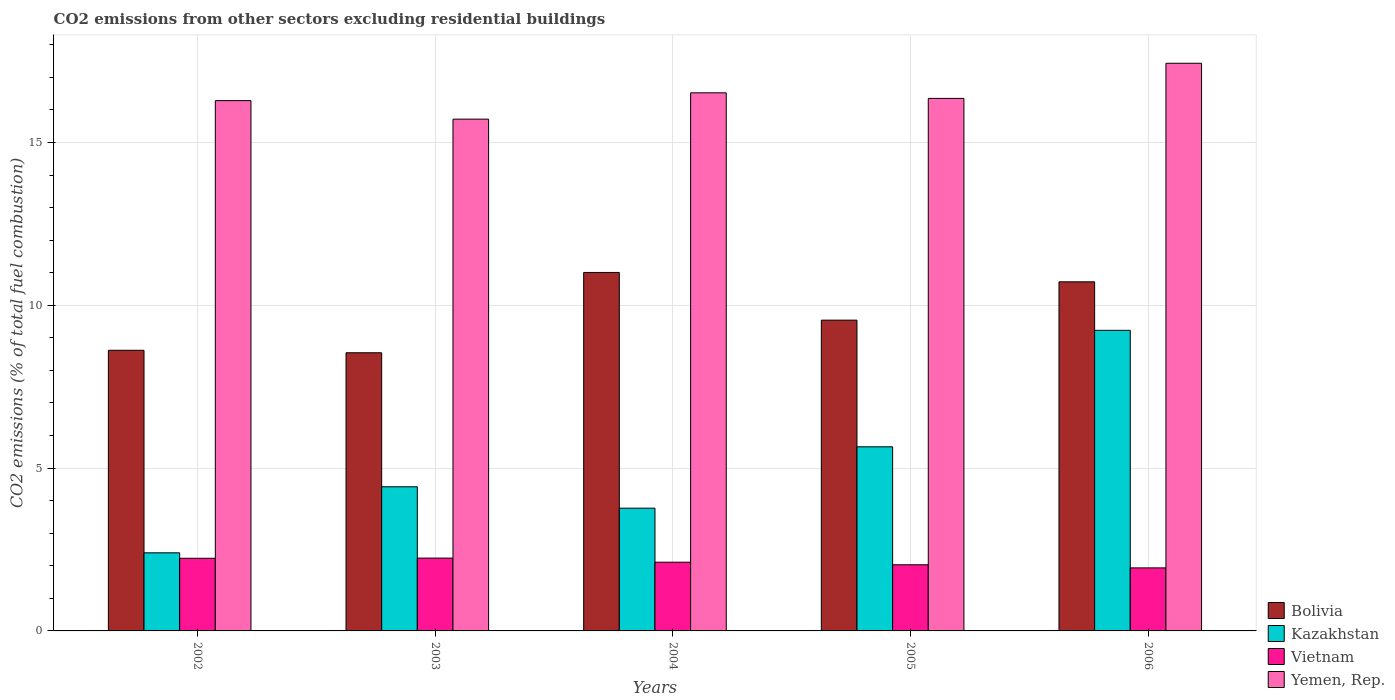How many groups of bars are there?
Make the answer very short. 5. Are the number of bars per tick equal to the number of legend labels?
Offer a very short reply. Yes. How many bars are there on the 2nd tick from the left?
Make the answer very short. 4. What is the total CO2 emitted in Bolivia in 2006?
Your response must be concise. 10.72. Across all years, what is the maximum total CO2 emitted in Bolivia?
Your answer should be very brief. 11.01. Across all years, what is the minimum total CO2 emitted in Bolivia?
Ensure brevity in your answer.  8.54. In which year was the total CO2 emitted in Yemen, Rep. minimum?
Your answer should be very brief. 2003. What is the total total CO2 emitted in Vietnam in the graph?
Give a very brief answer. 10.54. What is the difference between the total CO2 emitted in Bolivia in 2002 and that in 2005?
Give a very brief answer. -0.93. What is the difference between the total CO2 emitted in Yemen, Rep. in 2003 and the total CO2 emitted in Kazakhstan in 2004?
Provide a short and direct response. 11.95. What is the average total CO2 emitted in Bolivia per year?
Give a very brief answer. 9.69. In the year 2003, what is the difference between the total CO2 emitted in Vietnam and total CO2 emitted in Yemen, Rep.?
Offer a terse response. -13.48. In how many years, is the total CO2 emitted in Kazakhstan greater than 17?
Keep it short and to the point. 0. What is the ratio of the total CO2 emitted in Bolivia in 2005 to that in 2006?
Your response must be concise. 0.89. Is the total CO2 emitted in Vietnam in 2002 less than that in 2003?
Ensure brevity in your answer.  Yes. What is the difference between the highest and the second highest total CO2 emitted in Vietnam?
Provide a succinct answer. 0.01. What is the difference between the highest and the lowest total CO2 emitted in Bolivia?
Your answer should be compact. 2.47. In how many years, is the total CO2 emitted in Vietnam greater than the average total CO2 emitted in Vietnam taken over all years?
Offer a terse response. 3. Is the sum of the total CO2 emitted in Yemen, Rep. in 2003 and 2005 greater than the maximum total CO2 emitted in Vietnam across all years?
Provide a succinct answer. Yes. Is it the case that in every year, the sum of the total CO2 emitted in Kazakhstan and total CO2 emitted in Yemen, Rep. is greater than the sum of total CO2 emitted in Bolivia and total CO2 emitted in Vietnam?
Keep it short and to the point. No. What does the 2nd bar from the left in 2002 represents?
Make the answer very short. Kazakhstan. What does the 4th bar from the right in 2005 represents?
Make the answer very short. Bolivia. Is it the case that in every year, the sum of the total CO2 emitted in Vietnam and total CO2 emitted in Bolivia is greater than the total CO2 emitted in Kazakhstan?
Your response must be concise. Yes. How many bars are there?
Give a very brief answer. 20. Are all the bars in the graph horizontal?
Your response must be concise. No. Are the values on the major ticks of Y-axis written in scientific E-notation?
Ensure brevity in your answer.  No. Does the graph contain any zero values?
Give a very brief answer. No. Does the graph contain grids?
Ensure brevity in your answer.  Yes. How many legend labels are there?
Make the answer very short. 4. What is the title of the graph?
Your answer should be compact. CO2 emissions from other sectors excluding residential buildings. What is the label or title of the Y-axis?
Make the answer very short. CO2 emissions (% of total fuel combustion). What is the CO2 emissions (% of total fuel combustion) in Bolivia in 2002?
Provide a short and direct response. 8.62. What is the CO2 emissions (% of total fuel combustion) in Kazakhstan in 2002?
Your answer should be very brief. 2.4. What is the CO2 emissions (% of total fuel combustion) in Vietnam in 2002?
Your answer should be compact. 2.23. What is the CO2 emissions (% of total fuel combustion) in Yemen, Rep. in 2002?
Your answer should be compact. 16.29. What is the CO2 emissions (% of total fuel combustion) of Bolivia in 2003?
Offer a very short reply. 8.54. What is the CO2 emissions (% of total fuel combustion) in Kazakhstan in 2003?
Your answer should be very brief. 4.43. What is the CO2 emissions (% of total fuel combustion) of Vietnam in 2003?
Your answer should be compact. 2.24. What is the CO2 emissions (% of total fuel combustion) of Yemen, Rep. in 2003?
Provide a succinct answer. 15.72. What is the CO2 emissions (% of total fuel combustion) in Bolivia in 2004?
Keep it short and to the point. 11.01. What is the CO2 emissions (% of total fuel combustion) in Kazakhstan in 2004?
Offer a very short reply. 3.77. What is the CO2 emissions (% of total fuel combustion) of Vietnam in 2004?
Your answer should be very brief. 2.11. What is the CO2 emissions (% of total fuel combustion) in Yemen, Rep. in 2004?
Offer a very short reply. 16.53. What is the CO2 emissions (% of total fuel combustion) in Bolivia in 2005?
Offer a terse response. 9.54. What is the CO2 emissions (% of total fuel combustion) of Kazakhstan in 2005?
Your answer should be very brief. 5.65. What is the CO2 emissions (% of total fuel combustion) in Vietnam in 2005?
Provide a succinct answer. 2.03. What is the CO2 emissions (% of total fuel combustion) of Yemen, Rep. in 2005?
Offer a terse response. 16.35. What is the CO2 emissions (% of total fuel combustion) in Bolivia in 2006?
Keep it short and to the point. 10.72. What is the CO2 emissions (% of total fuel combustion) in Kazakhstan in 2006?
Offer a terse response. 9.23. What is the CO2 emissions (% of total fuel combustion) in Vietnam in 2006?
Offer a terse response. 1.94. What is the CO2 emissions (% of total fuel combustion) in Yemen, Rep. in 2006?
Give a very brief answer. 17.43. Across all years, what is the maximum CO2 emissions (% of total fuel combustion) of Bolivia?
Make the answer very short. 11.01. Across all years, what is the maximum CO2 emissions (% of total fuel combustion) in Kazakhstan?
Ensure brevity in your answer.  9.23. Across all years, what is the maximum CO2 emissions (% of total fuel combustion) in Vietnam?
Provide a succinct answer. 2.24. Across all years, what is the maximum CO2 emissions (% of total fuel combustion) in Yemen, Rep.?
Ensure brevity in your answer.  17.43. Across all years, what is the minimum CO2 emissions (% of total fuel combustion) in Bolivia?
Ensure brevity in your answer.  8.54. Across all years, what is the minimum CO2 emissions (% of total fuel combustion) of Kazakhstan?
Provide a succinct answer. 2.4. Across all years, what is the minimum CO2 emissions (% of total fuel combustion) of Vietnam?
Provide a short and direct response. 1.94. Across all years, what is the minimum CO2 emissions (% of total fuel combustion) of Yemen, Rep.?
Your answer should be very brief. 15.72. What is the total CO2 emissions (% of total fuel combustion) in Bolivia in the graph?
Give a very brief answer. 48.44. What is the total CO2 emissions (% of total fuel combustion) in Kazakhstan in the graph?
Make the answer very short. 25.48. What is the total CO2 emissions (% of total fuel combustion) in Vietnam in the graph?
Your answer should be very brief. 10.54. What is the total CO2 emissions (% of total fuel combustion) of Yemen, Rep. in the graph?
Give a very brief answer. 82.31. What is the difference between the CO2 emissions (% of total fuel combustion) of Bolivia in 2002 and that in 2003?
Your answer should be very brief. 0.08. What is the difference between the CO2 emissions (% of total fuel combustion) of Kazakhstan in 2002 and that in 2003?
Keep it short and to the point. -2.03. What is the difference between the CO2 emissions (% of total fuel combustion) in Vietnam in 2002 and that in 2003?
Provide a short and direct response. -0.01. What is the difference between the CO2 emissions (% of total fuel combustion) of Yemen, Rep. in 2002 and that in 2003?
Keep it short and to the point. 0.57. What is the difference between the CO2 emissions (% of total fuel combustion) of Bolivia in 2002 and that in 2004?
Your response must be concise. -2.39. What is the difference between the CO2 emissions (% of total fuel combustion) of Kazakhstan in 2002 and that in 2004?
Offer a very short reply. -1.37. What is the difference between the CO2 emissions (% of total fuel combustion) in Vietnam in 2002 and that in 2004?
Your answer should be compact. 0.12. What is the difference between the CO2 emissions (% of total fuel combustion) of Yemen, Rep. in 2002 and that in 2004?
Provide a short and direct response. -0.24. What is the difference between the CO2 emissions (% of total fuel combustion) of Bolivia in 2002 and that in 2005?
Keep it short and to the point. -0.93. What is the difference between the CO2 emissions (% of total fuel combustion) of Kazakhstan in 2002 and that in 2005?
Make the answer very short. -3.26. What is the difference between the CO2 emissions (% of total fuel combustion) in Vietnam in 2002 and that in 2005?
Make the answer very short. 0.2. What is the difference between the CO2 emissions (% of total fuel combustion) in Yemen, Rep. in 2002 and that in 2005?
Offer a very short reply. -0.07. What is the difference between the CO2 emissions (% of total fuel combustion) in Bolivia in 2002 and that in 2006?
Provide a short and direct response. -2.1. What is the difference between the CO2 emissions (% of total fuel combustion) of Kazakhstan in 2002 and that in 2006?
Offer a very short reply. -6.83. What is the difference between the CO2 emissions (% of total fuel combustion) in Vietnam in 2002 and that in 2006?
Ensure brevity in your answer.  0.3. What is the difference between the CO2 emissions (% of total fuel combustion) in Yemen, Rep. in 2002 and that in 2006?
Make the answer very short. -1.15. What is the difference between the CO2 emissions (% of total fuel combustion) in Bolivia in 2003 and that in 2004?
Your answer should be very brief. -2.47. What is the difference between the CO2 emissions (% of total fuel combustion) of Kazakhstan in 2003 and that in 2004?
Offer a terse response. 0.66. What is the difference between the CO2 emissions (% of total fuel combustion) in Vietnam in 2003 and that in 2004?
Provide a succinct answer. 0.13. What is the difference between the CO2 emissions (% of total fuel combustion) of Yemen, Rep. in 2003 and that in 2004?
Keep it short and to the point. -0.81. What is the difference between the CO2 emissions (% of total fuel combustion) in Bolivia in 2003 and that in 2005?
Ensure brevity in your answer.  -1. What is the difference between the CO2 emissions (% of total fuel combustion) of Kazakhstan in 2003 and that in 2005?
Offer a very short reply. -1.23. What is the difference between the CO2 emissions (% of total fuel combustion) in Vietnam in 2003 and that in 2005?
Offer a terse response. 0.21. What is the difference between the CO2 emissions (% of total fuel combustion) of Yemen, Rep. in 2003 and that in 2005?
Your answer should be very brief. -0.64. What is the difference between the CO2 emissions (% of total fuel combustion) in Bolivia in 2003 and that in 2006?
Your answer should be compact. -2.18. What is the difference between the CO2 emissions (% of total fuel combustion) in Kazakhstan in 2003 and that in 2006?
Provide a short and direct response. -4.81. What is the difference between the CO2 emissions (% of total fuel combustion) in Vietnam in 2003 and that in 2006?
Your answer should be compact. 0.3. What is the difference between the CO2 emissions (% of total fuel combustion) of Yemen, Rep. in 2003 and that in 2006?
Keep it short and to the point. -1.72. What is the difference between the CO2 emissions (% of total fuel combustion) in Bolivia in 2004 and that in 2005?
Provide a short and direct response. 1.47. What is the difference between the CO2 emissions (% of total fuel combustion) of Kazakhstan in 2004 and that in 2005?
Your answer should be very brief. -1.88. What is the difference between the CO2 emissions (% of total fuel combustion) in Vietnam in 2004 and that in 2005?
Offer a very short reply. 0.08. What is the difference between the CO2 emissions (% of total fuel combustion) in Yemen, Rep. in 2004 and that in 2005?
Ensure brevity in your answer.  0.17. What is the difference between the CO2 emissions (% of total fuel combustion) of Bolivia in 2004 and that in 2006?
Offer a terse response. 0.29. What is the difference between the CO2 emissions (% of total fuel combustion) in Kazakhstan in 2004 and that in 2006?
Your response must be concise. -5.46. What is the difference between the CO2 emissions (% of total fuel combustion) of Vietnam in 2004 and that in 2006?
Your response must be concise. 0.17. What is the difference between the CO2 emissions (% of total fuel combustion) in Yemen, Rep. in 2004 and that in 2006?
Your answer should be very brief. -0.91. What is the difference between the CO2 emissions (% of total fuel combustion) in Bolivia in 2005 and that in 2006?
Keep it short and to the point. -1.18. What is the difference between the CO2 emissions (% of total fuel combustion) of Kazakhstan in 2005 and that in 2006?
Make the answer very short. -3.58. What is the difference between the CO2 emissions (% of total fuel combustion) of Vietnam in 2005 and that in 2006?
Provide a succinct answer. 0.1. What is the difference between the CO2 emissions (% of total fuel combustion) of Yemen, Rep. in 2005 and that in 2006?
Offer a terse response. -1.08. What is the difference between the CO2 emissions (% of total fuel combustion) in Bolivia in 2002 and the CO2 emissions (% of total fuel combustion) in Kazakhstan in 2003?
Keep it short and to the point. 4.19. What is the difference between the CO2 emissions (% of total fuel combustion) in Bolivia in 2002 and the CO2 emissions (% of total fuel combustion) in Vietnam in 2003?
Provide a succinct answer. 6.38. What is the difference between the CO2 emissions (% of total fuel combustion) in Bolivia in 2002 and the CO2 emissions (% of total fuel combustion) in Yemen, Rep. in 2003?
Provide a succinct answer. -7.1. What is the difference between the CO2 emissions (% of total fuel combustion) of Kazakhstan in 2002 and the CO2 emissions (% of total fuel combustion) of Vietnam in 2003?
Offer a terse response. 0.16. What is the difference between the CO2 emissions (% of total fuel combustion) in Kazakhstan in 2002 and the CO2 emissions (% of total fuel combustion) in Yemen, Rep. in 2003?
Your answer should be very brief. -13.32. What is the difference between the CO2 emissions (% of total fuel combustion) of Vietnam in 2002 and the CO2 emissions (% of total fuel combustion) of Yemen, Rep. in 2003?
Your answer should be very brief. -13.49. What is the difference between the CO2 emissions (% of total fuel combustion) in Bolivia in 2002 and the CO2 emissions (% of total fuel combustion) in Kazakhstan in 2004?
Your response must be concise. 4.85. What is the difference between the CO2 emissions (% of total fuel combustion) in Bolivia in 2002 and the CO2 emissions (% of total fuel combustion) in Vietnam in 2004?
Give a very brief answer. 6.51. What is the difference between the CO2 emissions (% of total fuel combustion) of Bolivia in 2002 and the CO2 emissions (% of total fuel combustion) of Yemen, Rep. in 2004?
Make the answer very short. -7.91. What is the difference between the CO2 emissions (% of total fuel combustion) of Kazakhstan in 2002 and the CO2 emissions (% of total fuel combustion) of Vietnam in 2004?
Provide a succinct answer. 0.29. What is the difference between the CO2 emissions (% of total fuel combustion) in Kazakhstan in 2002 and the CO2 emissions (% of total fuel combustion) in Yemen, Rep. in 2004?
Provide a succinct answer. -14.13. What is the difference between the CO2 emissions (% of total fuel combustion) in Vietnam in 2002 and the CO2 emissions (% of total fuel combustion) in Yemen, Rep. in 2004?
Ensure brevity in your answer.  -14.29. What is the difference between the CO2 emissions (% of total fuel combustion) in Bolivia in 2002 and the CO2 emissions (% of total fuel combustion) in Kazakhstan in 2005?
Your response must be concise. 2.96. What is the difference between the CO2 emissions (% of total fuel combustion) of Bolivia in 2002 and the CO2 emissions (% of total fuel combustion) of Vietnam in 2005?
Keep it short and to the point. 6.59. What is the difference between the CO2 emissions (% of total fuel combustion) in Bolivia in 2002 and the CO2 emissions (% of total fuel combustion) in Yemen, Rep. in 2005?
Your response must be concise. -7.74. What is the difference between the CO2 emissions (% of total fuel combustion) in Kazakhstan in 2002 and the CO2 emissions (% of total fuel combustion) in Vietnam in 2005?
Your answer should be compact. 0.37. What is the difference between the CO2 emissions (% of total fuel combustion) of Kazakhstan in 2002 and the CO2 emissions (% of total fuel combustion) of Yemen, Rep. in 2005?
Give a very brief answer. -13.96. What is the difference between the CO2 emissions (% of total fuel combustion) of Vietnam in 2002 and the CO2 emissions (% of total fuel combustion) of Yemen, Rep. in 2005?
Your response must be concise. -14.12. What is the difference between the CO2 emissions (% of total fuel combustion) of Bolivia in 2002 and the CO2 emissions (% of total fuel combustion) of Kazakhstan in 2006?
Offer a very short reply. -0.61. What is the difference between the CO2 emissions (% of total fuel combustion) of Bolivia in 2002 and the CO2 emissions (% of total fuel combustion) of Vietnam in 2006?
Keep it short and to the point. 6.68. What is the difference between the CO2 emissions (% of total fuel combustion) in Bolivia in 2002 and the CO2 emissions (% of total fuel combustion) in Yemen, Rep. in 2006?
Provide a short and direct response. -8.81. What is the difference between the CO2 emissions (% of total fuel combustion) in Kazakhstan in 2002 and the CO2 emissions (% of total fuel combustion) in Vietnam in 2006?
Make the answer very short. 0.46. What is the difference between the CO2 emissions (% of total fuel combustion) in Kazakhstan in 2002 and the CO2 emissions (% of total fuel combustion) in Yemen, Rep. in 2006?
Your answer should be compact. -15.03. What is the difference between the CO2 emissions (% of total fuel combustion) of Vietnam in 2002 and the CO2 emissions (% of total fuel combustion) of Yemen, Rep. in 2006?
Provide a short and direct response. -15.2. What is the difference between the CO2 emissions (% of total fuel combustion) in Bolivia in 2003 and the CO2 emissions (% of total fuel combustion) in Kazakhstan in 2004?
Provide a succinct answer. 4.77. What is the difference between the CO2 emissions (% of total fuel combustion) of Bolivia in 2003 and the CO2 emissions (% of total fuel combustion) of Vietnam in 2004?
Your answer should be compact. 6.43. What is the difference between the CO2 emissions (% of total fuel combustion) in Bolivia in 2003 and the CO2 emissions (% of total fuel combustion) in Yemen, Rep. in 2004?
Keep it short and to the point. -7.98. What is the difference between the CO2 emissions (% of total fuel combustion) in Kazakhstan in 2003 and the CO2 emissions (% of total fuel combustion) in Vietnam in 2004?
Provide a succinct answer. 2.32. What is the difference between the CO2 emissions (% of total fuel combustion) in Kazakhstan in 2003 and the CO2 emissions (% of total fuel combustion) in Yemen, Rep. in 2004?
Your answer should be compact. -12.1. What is the difference between the CO2 emissions (% of total fuel combustion) of Vietnam in 2003 and the CO2 emissions (% of total fuel combustion) of Yemen, Rep. in 2004?
Your response must be concise. -14.29. What is the difference between the CO2 emissions (% of total fuel combustion) of Bolivia in 2003 and the CO2 emissions (% of total fuel combustion) of Kazakhstan in 2005?
Provide a short and direct response. 2.89. What is the difference between the CO2 emissions (% of total fuel combustion) of Bolivia in 2003 and the CO2 emissions (% of total fuel combustion) of Vietnam in 2005?
Provide a short and direct response. 6.51. What is the difference between the CO2 emissions (% of total fuel combustion) of Bolivia in 2003 and the CO2 emissions (% of total fuel combustion) of Yemen, Rep. in 2005?
Offer a terse response. -7.81. What is the difference between the CO2 emissions (% of total fuel combustion) in Kazakhstan in 2003 and the CO2 emissions (% of total fuel combustion) in Vietnam in 2005?
Keep it short and to the point. 2.4. What is the difference between the CO2 emissions (% of total fuel combustion) of Kazakhstan in 2003 and the CO2 emissions (% of total fuel combustion) of Yemen, Rep. in 2005?
Ensure brevity in your answer.  -11.93. What is the difference between the CO2 emissions (% of total fuel combustion) of Vietnam in 2003 and the CO2 emissions (% of total fuel combustion) of Yemen, Rep. in 2005?
Your answer should be compact. -14.12. What is the difference between the CO2 emissions (% of total fuel combustion) in Bolivia in 2003 and the CO2 emissions (% of total fuel combustion) in Kazakhstan in 2006?
Give a very brief answer. -0.69. What is the difference between the CO2 emissions (% of total fuel combustion) in Bolivia in 2003 and the CO2 emissions (% of total fuel combustion) in Vietnam in 2006?
Provide a succinct answer. 6.61. What is the difference between the CO2 emissions (% of total fuel combustion) in Bolivia in 2003 and the CO2 emissions (% of total fuel combustion) in Yemen, Rep. in 2006?
Offer a very short reply. -8.89. What is the difference between the CO2 emissions (% of total fuel combustion) in Kazakhstan in 2003 and the CO2 emissions (% of total fuel combustion) in Vietnam in 2006?
Provide a short and direct response. 2.49. What is the difference between the CO2 emissions (% of total fuel combustion) of Kazakhstan in 2003 and the CO2 emissions (% of total fuel combustion) of Yemen, Rep. in 2006?
Make the answer very short. -13.01. What is the difference between the CO2 emissions (% of total fuel combustion) of Vietnam in 2003 and the CO2 emissions (% of total fuel combustion) of Yemen, Rep. in 2006?
Your response must be concise. -15.2. What is the difference between the CO2 emissions (% of total fuel combustion) of Bolivia in 2004 and the CO2 emissions (% of total fuel combustion) of Kazakhstan in 2005?
Offer a terse response. 5.35. What is the difference between the CO2 emissions (% of total fuel combustion) in Bolivia in 2004 and the CO2 emissions (% of total fuel combustion) in Vietnam in 2005?
Offer a very short reply. 8.98. What is the difference between the CO2 emissions (% of total fuel combustion) of Bolivia in 2004 and the CO2 emissions (% of total fuel combustion) of Yemen, Rep. in 2005?
Give a very brief answer. -5.34. What is the difference between the CO2 emissions (% of total fuel combustion) in Kazakhstan in 2004 and the CO2 emissions (% of total fuel combustion) in Vietnam in 2005?
Make the answer very short. 1.74. What is the difference between the CO2 emissions (% of total fuel combustion) of Kazakhstan in 2004 and the CO2 emissions (% of total fuel combustion) of Yemen, Rep. in 2005?
Your answer should be compact. -12.58. What is the difference between the CO2 emissions (% of total fuel combustion) of Vietnam in 2004 and the CO2 emissions (% of total fuel combustion) of Yemen, Rep. in 2005?
Provide a succinct answer. -14.24. What is the difference between the CO2 emissions (% of total fuel combustion) in Bolivia in 2004 and the CO2 emissions (% of total fuel combustion) in Kazakhstan in 2006?
Ensure brevity in your answer.  1.78. What is the difference between the CO2 emissions (% of total fuel combustion) of Bolivia in 2004 and the CO2 emissions (% of total fuel combustion) of Vietnam in 2006?
Provide a short and direct response. 9.07. What is the difference between the CO2 emissions (% of total fuel combustion) of Bolivia in 2004 and the CO2 emissions (% of total fuel combustion) of Yemen, Rep. in 2006?
Your answer should be very brief. -6.42. What is the difference between the CO2 emissions (% of total fuel combustion) of Kazakhstan in 2004 and the CO2 emissions (% of total fuel combustion) of Vietnam in 2006?
Provide a short and direct response. 1.83. What is the difference between the CO2 emissions (% of total fuel combustion) in Kazakhstan in 2004 and the CO2 emissions (% of total fuel combustion) in Yemen, Rep. in 2006?
Give a very brief answer. -13.66. What is the difference between the CO2 emissions (% of total fuel combustion) of Vietnam in 2004 and the CO2 emissions (% of total fuel combustion) of Yemen, Rep. in 2006?
Provide a short and direct response. -15.32. What is the difference between the CO2 emissions (% of total fuel combustion) in Bolivia in 2005 and the CO2 emissions (% of total fuel combustion) in Kazakhstan in 2006?
Keep it short and to the point. 0.31. What is the difference between the CO2 emissions (% of total fuel combustion) in Bolivia in 2005 and the CO2 emissions (% of total fuel combustion) in Vietnam in 2006?
Provide a short and direct response. 7.61. What is the difference between the CO2 emissions (% of total fuel combustion) in Bolivia in 2005 and the CO2 emissions (% of total fuel combustion) in Yemen, Rep. in 2006?
Give a very brief answer. -7.89. What is the difference between the CO2 emissions (% of total fuel combustion) of Kazakhstan in 2005 and the CO2 emissions (% of total fuel combustion) of Vietnam in 2006?
Offer a very short reply. 3.72. What is the difference between the CO2 emissions (% of total fuel combustion) in Kazakhstan in 2005 and the CO2 emissions (% of total fuel combustion) in Yemen, Rep. in 2006?
Provide a succinct answer. -11.78. What is the difference between the CO2 emissions (% of total fuel combustion) of Vietnam in 2005 and the CO2 emissions (% of total fuel combustion) of Yemen, Rep. in 2006?
Your answer should be compact. -15.4. What is the average CO2 emissions (% of total fuel combustion) in Bolivia per year?
Your response must be concise. 9.69. What is the average CO2 emissions (% of total fuel combustion) in Kazakhstan per year?
Provide a succinct answer. 5.1. What is the average CO2 emissions (% of total fuel combustion) of Vietnam per year?
Give a very brief answer. 2.11. What is the average CO2 emissions (% of total fuel combustion) of Yemen, Rep. per year?
Provide a succinct answer. 16.46. In the year 2002, what is the difference between the CO2 emissions (% of total fuel combustion) in Bolivia and CO2 emissions (% of total fuel combustion) in Kazakhstan?
Offer a terse response. 6.22. In the year 2002, what is the difference between the CO2 emissions (% of total fuel combustion) of Bolivia and CO2 emissions (% of total fuel combustion) of Vietnam?
Your response must be concise. 6.39. In the year 2002, what is the difference between the CO2 emissions (% of total fuel combustion) of Bolivia and CO2 emissions (% of total fuel combustion) of Yemen, Rep.?
Give a very brief answer. -7.67. In the year 2002, what is the difference between the CO2 emissions (% of total fuel combustion) in Kazakhstan and CO2 emissions (% of total fuel combustion) in Vietnam?
Your answer should be compact. 0.17. In the year 2002, what is the difference between the CO2 emissions (% of total fuel combustion) of Kazakhstan and CO2 emissions (% of total fuel combustion) of Yemen, Rep.?
Provide a succinct answer. -13.89. In the year 2002, what is the difference between the CO2 emissions (% of total fuel combustion) of Vietnam and CO2 emissions (% of total fuel combustion) of Yemen, Rep.?
Ensure brevity in your answer.  -14.05. In the year 2003, what is the difference between the CO2 emissions (% of total fuel combustion) in Bolivia and CO2 emissions (% of total fuel combustion) in Kazakhstan?
Your answer should be compact. 4.12. In the year 2003, what is the difference between the CO2 emissions (% of total fuel combustion) in Bolivia and CO2 emissions (% of total fuel combustion) in Vietnam?
Your response must be concise. 6.31. In the year 2003, what is the difference between the CO2 emissions (% of total fuel combustion) in Bolivia and CO2 emissions (% of total fuel combustion) in Yemen, Rep.?
Make the answer very short. -7.17. In the year 2003, what is the difference between the CO2 emissions (% of total fuel combustion) in Kazakhstan and CO2 emissions (% of total fuel combustion) in Vietnam?
Provide a short and direct response. 2.19. In the year 2003, what is the difference between the CO2 emissions (% of total fuel combustion) in Kazakhstan and CO2 emissions (% of total fuel combustion) in Yemen, Rep.?
Keep it short and to the point. -11.29. In the year 2003, what is the difference between the CO2 emissions (% of total fuel combustion) of Vietnam and CO2 emissions (% of total fuel combustion) of Yemen, Rep.?
Your answer should be compact. -13.48. In the year 2004, what is the difference between the CO2 emissions (% of total fuel combustion) of Bolivia and CO2 emissions (% of total fuel combustion) of Kazakhstan?
Your answer should be very brief. 7.24. In the year 2004, what is the difference between the CO2 emissions (% of total fuel combustion) in Bolivia and CO2 emissions (% of total fuel combustion) in Vietnam?
Provide a short and direct response. 8.9. In the year 2004, what is the difference between the CO2 emissions (% of total fuel combustion) of Bolivia and CO2 emissions (% of total fuel combustion) of Yemen, Rep.?
Keep it short and to the point. -5.52. In the year 2004, what is the difference between the CO2 emissions (% of total fuel combustion) in Kazakhstan and CO2 emissions (% of total fuel combustion) in Vietnam?
Your answer should be compact. 1.66. In the year 2004, what is the difference between the CO2 emissions (% of total fuel combustion) of Kazakhstan and CO2 emissions (% of total fuel combustion) of Yemen, Rep.?
Provide a succinct answer. -12.76. In the year 2004, what is the difference between the CO2 emissions (% of total fuel combustion) of Vietnam and CO2 emissions (% of total fuel combustion) of Yemen, Rep.?
Offer a very short reply. -14.42. In the year 2005, what is the difference between the CO2 emissions (% of total fuel combustion) of Bolivia and CO2 emissions (% of total fuel combustion) of Kazakhstan?
Make the answer very short. 3.89. In the year 2005, what is the difference between the CO2 emissions (% of total fuel combustion) in Bolivia and CO2 emissions (% of total fuel combustion) in Vietnam?
Give a very brief answer. 7.51. In the year 2005, what is the difference between the CO2 emissions (% of total fuel combustion) in Bolivia and CO2 emissions (% of total fuel combustion) in Yemen, Rep.?
Offer a terse response. -6.81. In the year 2005, what is the difference between the CO2 emissions (% of total fuel combustion) in Kazakhstan and CO2 emissions (% of total fuel combustion) in Vietnam?
Provide a short and direct response. 3.62. In the year 2005, what is the difference between the CO2 emissions (% of total fuel combustion) of Kazakhstan and CO2 emissions (% of total fuel combustion) of Yemen, Rep.?
Provide a short and direct response. -10.7. In the year 2005, what is the difference between the CO2 emissions (% of total fuel combustion) of Vietnam and CO2 emissions (% of total fuel combustion) of Yemen, Rep.?
Ensure brevity in your answer.  -14.32. In the year 2006, what is the difference between the CO2 emissions (% of total fuel combustion) of Bolivia and CO2 emissions (% of total fuel combustion) of Kazakhstan?
Provide a succinct answer. 1.49. In the year 2006, what is the difference between the CO2 emissions (% of total fuel combustion) in Bolivia and CO2 emissions (% of total fuel combustion) in Vietnam?
Make the answer very short. 8.79. In the year 2006, what is the difference between the CO2 emissions (% of total fuel combustion) of Bolivia and CO2 emissions (% of total fuel combustion) of Yemen, Rep.?
Make the answer very short. -6.71. In the year 2006, what is the difference between the CO2 emissions (% of total fuel combustion) of Kazakhstan and CO2 emissions (% of total fuel combustion) of Vietnam?
Your answer should be very brief. 7.3. In the year 2006, what is the difference between the CO2 emissions (% of total fuel combustion) in Kazakhstan and CO2 emissions (% of total fuel combustion) in Yemen, Rep.?
Provide a succinct answer. -8.2. In the year 2006, what is the difference between the CO2 emissions (% of total fuel combustion) in Vietnam and CO2 emissions (% of total fuel combustion) in Yemen, Rep.?
Keep it short and to the point. -15.5. What is the ratio of the CO2 emissions (% of total fuel combustion) of Bolivia in 2002 to that in 2003?
Ensure brevity in your answer.  1.01. What is the ratio of the CO2 emissions (% of total fuel combustion) in Kazakhstan in 2002 to that in 2003?
Your answer should be very brief. 0.54. What is the ratio of the CO2 emissions (% of total fuel combustion) in Yemen, Rep. in 2002 to that in 2003?
Your answer should be compact. 1.04. What is the ratio of the CO2 emissions (% of total fuel combustion) of Bolivia in 2002 to that in 2004?
Your answer should be very brief. 0.78. What is the ratio of the CO2 emissions (% of total fuel combustion) in Kazakhstan in 2002 to that in 2004?
Your answer should be very brief. 0.64. What is the ratio of the CO2 emissions (% of total fuel combustion) of Vietnam in 2002 to that in 2004?
Keep it short and to the point. 1.06. What is the ratio of the CO2 emissions (% of total fuel combustion) in Yemen, Rep. in 2002 to that in 2004?
Give a very brief answer. 0.99. What is the ratio of the CO2 emissions (% of total fuel combustion) in Bolivia in 2002 to that in 2005?
Ensure brevity in your answer.  0.9. What is the ratio of the CO2 emissions (% of total fuel combustion) in Kazakhstan in 2002 to that in 2005?
Offer a very short reply. 0.42. What is the ratio of the CO2 emissions (% of total fuel combustion) of Vietnam in 2002 to that in 2005?
Offer a terse response. 1.1. What is the ratio of the CO2 emissions (% of total fuel combustion) of Bolivia in 2002 to that in 2006?
Make the answer very short. 0.8. What is the ratio of the CO2 emissions (% of total fuel combustion) in Kazakhstan in 2002 to that in 2006?
Offer a terse response. 0.26. What is the ratio of the CO2 emissions (% of total fuel combustion) in Vietnam in 2002 to that in 2006?
Make the answer very short. 1.15. What is the ratio of the CO2 emissions (% of total fuel combustion) in Yemen, Rep. in 2002 to that in 2006?
Offer a terse response. 0.93. What is the ratio of the CO2 emissions (% of total fuel combustion) in Bolivia in 2003 to that in 2004?
Your answer should be compact. 0.78. What is the ratio of the CO2 emissions (% of total fuel combustion) in Kazakhstan in 2003 to that in 2004?
Provide a short and direct response. 1.17. What is the ratio of the CO2 emissions (% of total fuel combustion) in Vietnam in 2003 to that in 2004?
Ensure brevity in your answer.  1.06. What is the ratio of the CO2 emissions (% of total fuel combustion) in Yemen, Rep. in 2003 to that in 2004?
Provide a succinct answer. 0.95. What is the ratio of the CO2 emissions (% of total fuel combustion) of Bolivia in 2003 to that in 2005?
Your response must be concise. 0.9. What is the ratio of the CO2 emissions (% of total fuel combustion) in Kazakhstan in 2003 to that in 2005?
Your answer should be compact. 0.78. What is the ratio of the CO2 emissions (% of total fuel combustion) of Vietnam in 2003 to that in 2005?
Provide a succinct answer. 1.1. What is the ratio of the CO2 emissions (% of total fuel combustion) of Yemen, Rep. in 2003 to that in 2005?
Offer a terse response. 0.96. What is the ratio of the CO2 emissions (% of total fuel combustion) in Bolivia in 2003 to that in 2006?
Keep it short and to the point. 0.8. What is the ratio of the CO2 emissions (% of total fuel combustion) of Kazakhstan in 2003 to that in 2006?
Offer a terse response. 0.48. What is the ratio of the CO2 emissions (% of total fuel combustion) of Vietnam in 2003 to that in 2006?
Provide a short and direct response. 1.16. What is the ratio of the CO2 emissions (% of total fuel combustion) of Yemen, Rep. in 2003 to that in 2006?
Make the answer very short. 0.9. What is the ratio of the CO2 emissions (% of total fuel combustion) in Bolivia in 2004 to that in 2005?
Make the answer very short. 1.15. What is the ratio of the CO2 emissions (% of total fuel combustion) of Kazakhstan in 2004 to that in 2005?
Ensure brevity in your answer.  0.67. What is the ratio of the CO2 emissions (% of total fuel combustion) in Vietnam in 2004 to that in 2005?
Your answer should be very brief. 1.04. What is the ratio of the CO2 emissions (% of total fuel combustion) in Yemen, Rep. in 2004 to that in 2005?
Give a very brief answer. 1.01. What is the ratio of the CO2 emissions (% of total fuel combustion) in Bolivia in 2004 to that in 2006?
Keep it short and to the point. 1.03. What is the ratio of the CO2 emissions (% of total fuel combustion) in Kazakhstan in 2004 to that in 2006?
Provide a short and direct response. 0.41. What is the ratio of the CO2 emissions (% of total fuel combustion) of Vietnam in 2004 to that in 2006?
Your answer should be compact. 1.09. What is the ratio of the CO2 emissions (% of total fuel combustion) in Yemen, Rep. in 2004 to that in 2006?
Offer a very short reply. 0.95. What is the ratio of the CO2 emissions (% of total fuel combustion) in Bolivia in 2005 to that in 2006?
Give a very brief answer. 0.89. What is the ratio of the CO2 emissions (% of total fuel combustion) of Kazakhstan in 2005 to that in 2006?
Give a very brief answer. 0.61. What is the ratio of the CO2 emissions (% of total fuel combustion) in Vietnam in 2005 to that in 2006?
Your response must be concise. 1.05. What is the ratio of the CO2 emissions (% of total fuel combustion) of Yemen, Rep. in 2005 to that in 2006?
Provide a short and direct response. 0.94. What is the difference between the highest and the second highest CO2 emissions (% of total fuel combustion) in Bolivia?
Your answer should be very brief. 0.29. What is the difference between the highest and the second highest CO2 emissions (% of total fuel combustion) in Kazakhstan?
Keep it short and to the point. 3.58. What is the difference between the highest and the second highest CO2 emissions (% of total fuel combustion) in Vietnam?
Make the answer very short. 0.01. What is the difference between the highest and the second highest CO2 emissions (% of total fuel combustion) in Yemen, Rep.?
Your answer should be very brief. 0.91. What is the difference between the highest and the lowest CO2 emissions (% of total fuel combustion) in Bolivia?
Your answer should be very brief. 2.47. What is the difference between the highest and the lowest CO2 emissions (% of total fuel combustion) in Kazakhstan?
Keep it short and to the point. 6.83. What is the difference between the highest and the lowest CO2 emissions (% of total fuel combustion) in Vietnam?
Give a very brief answer. 0.3. What is the difference between the highest and the lowest CO2 emissions (% of total fuel combustion) of Yemen, Rep.?
Ensure brevity in your answer.  1.72. 